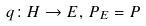Convert formula to latex. <formula><loc_0><loc_0><loc_500><loc_500>q \colon H \rightarrow E , \, P _ { E } = P</formula> 